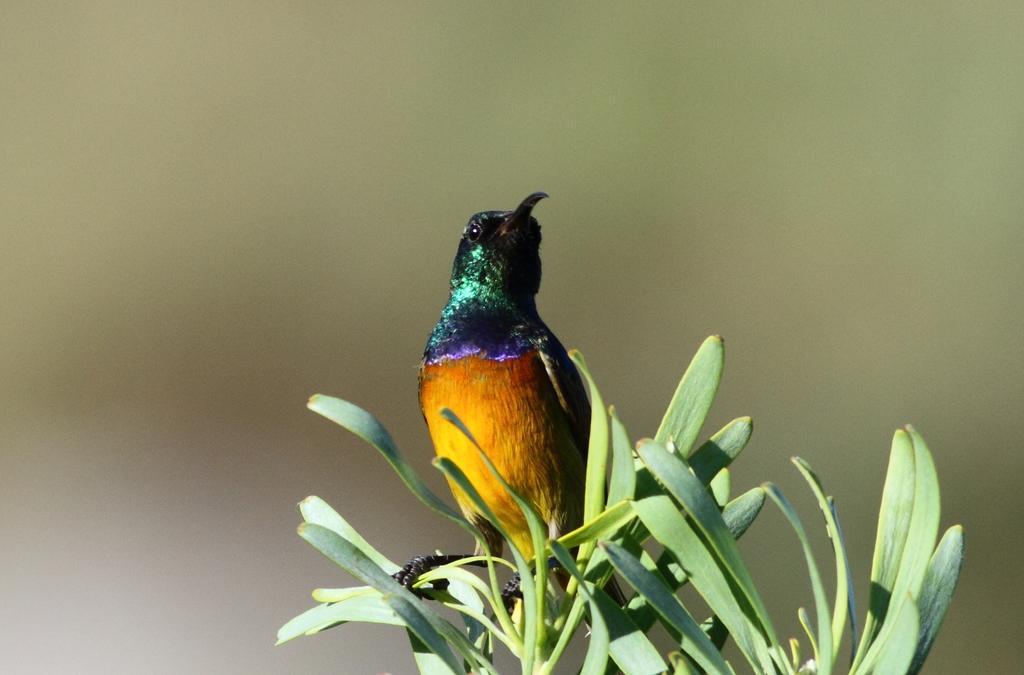Can you describe this image briefly? In this image I can see a bird which is yellow, orange, violet, green and black in color on a plant which is green in color. I can see the blurry background. 